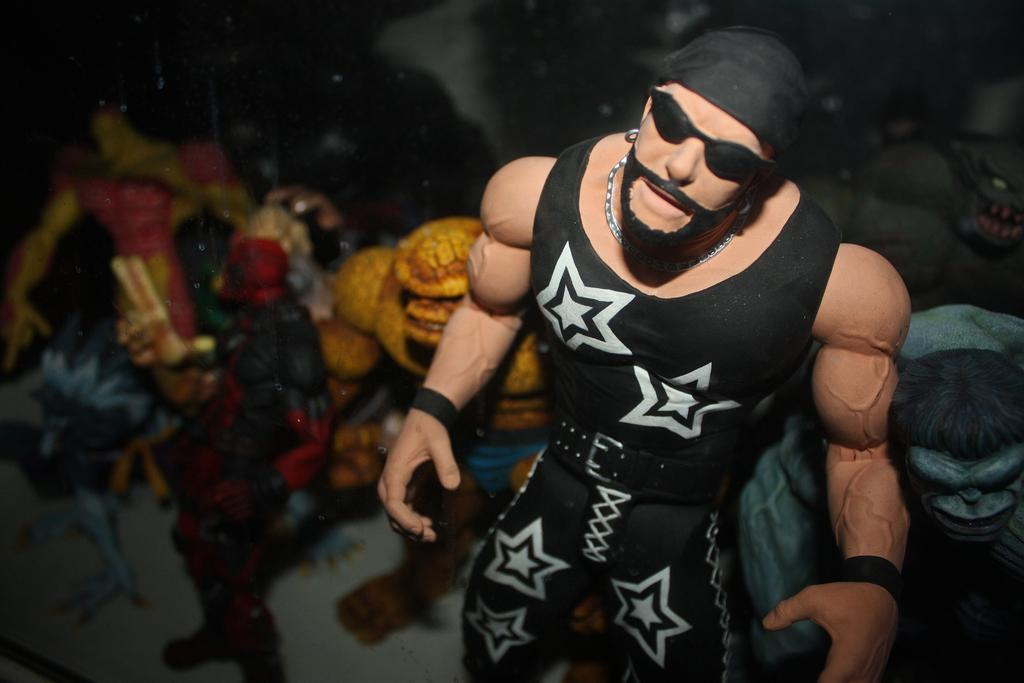What object is located on the right side of the image? There is a toy on the right side of the image. Can you describe any other toys visible in the image? There are other toys in the background of the image. How many tomatoes are on the toy in the image? There are no tomatoes present in the image. What type of deer can be seen interacting with the toys in the image? There are no deer present in the image; it only features toys. 